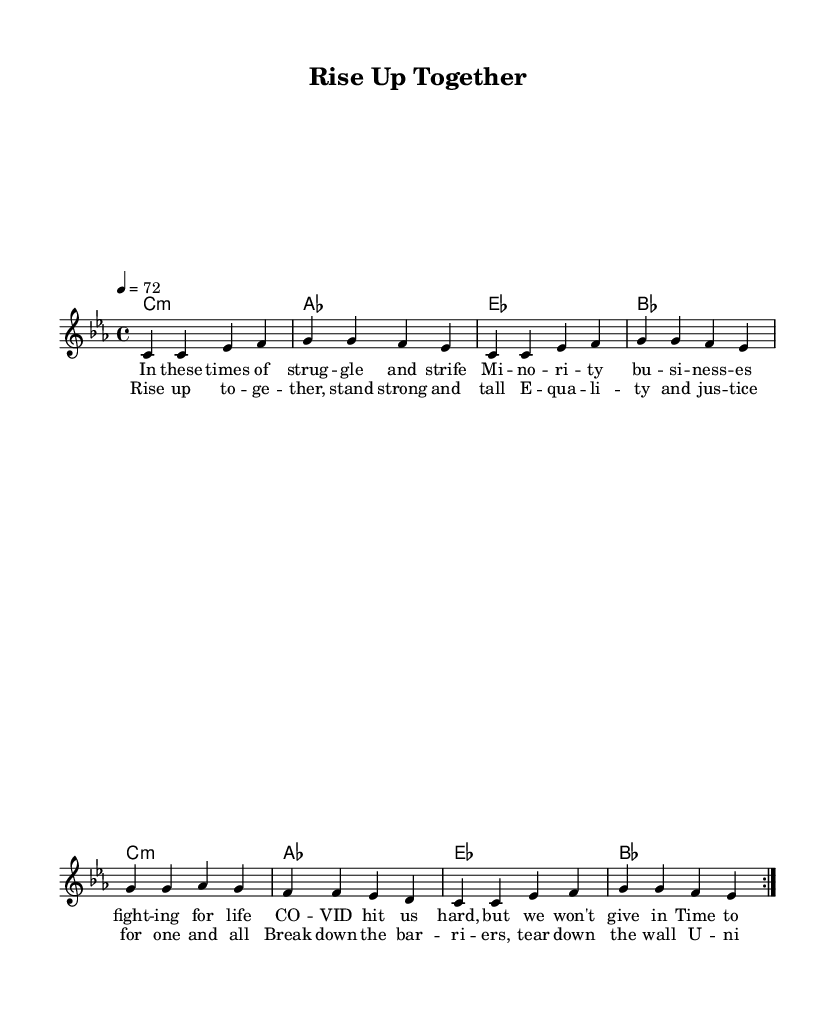What is the key signature of this music? The key signature is C minor, which has three flats (B, E, and A). C minor is the relative minor of E flat major.
Answer: C minor What is the time signature of this piece? The time signature indicated in the music sheet is 4/4, meaning there are four beats per measure and a quarter note receives one beat.
Answer: 4/4 What is the tempo marking in this music? The tempo marking is indicated as 4 = 72, which specifies that there are 72 beats per minute. This is a moderate tempo for the piece.
Answer: 72 How many repetitions of the melody are indicated? The sheet music indicates that the melody is to be repeated twice, denoted by the "repeat volta 2" instruction.
Answer: 2 What is the main theme of the lyrics in the chorus? The main theme of the chorus focuses on unity and social justice, addressing the need for equality and collective action against barriers.
Answer: Unity and social justice What type of chords are used in the harmony section? The harmony section uses minor and major chords, specifically C minor, A flat major, E flat major, and B flat major. This combination exemplifies the tonality of the piece.
Answer: Minor and major chords What social issue does the song address? The song addresses social inequality and the struggles faced by minority-owned businesses during the COVID-19 pandemic, advocating for justice and equity.
Answer: Social inequality 